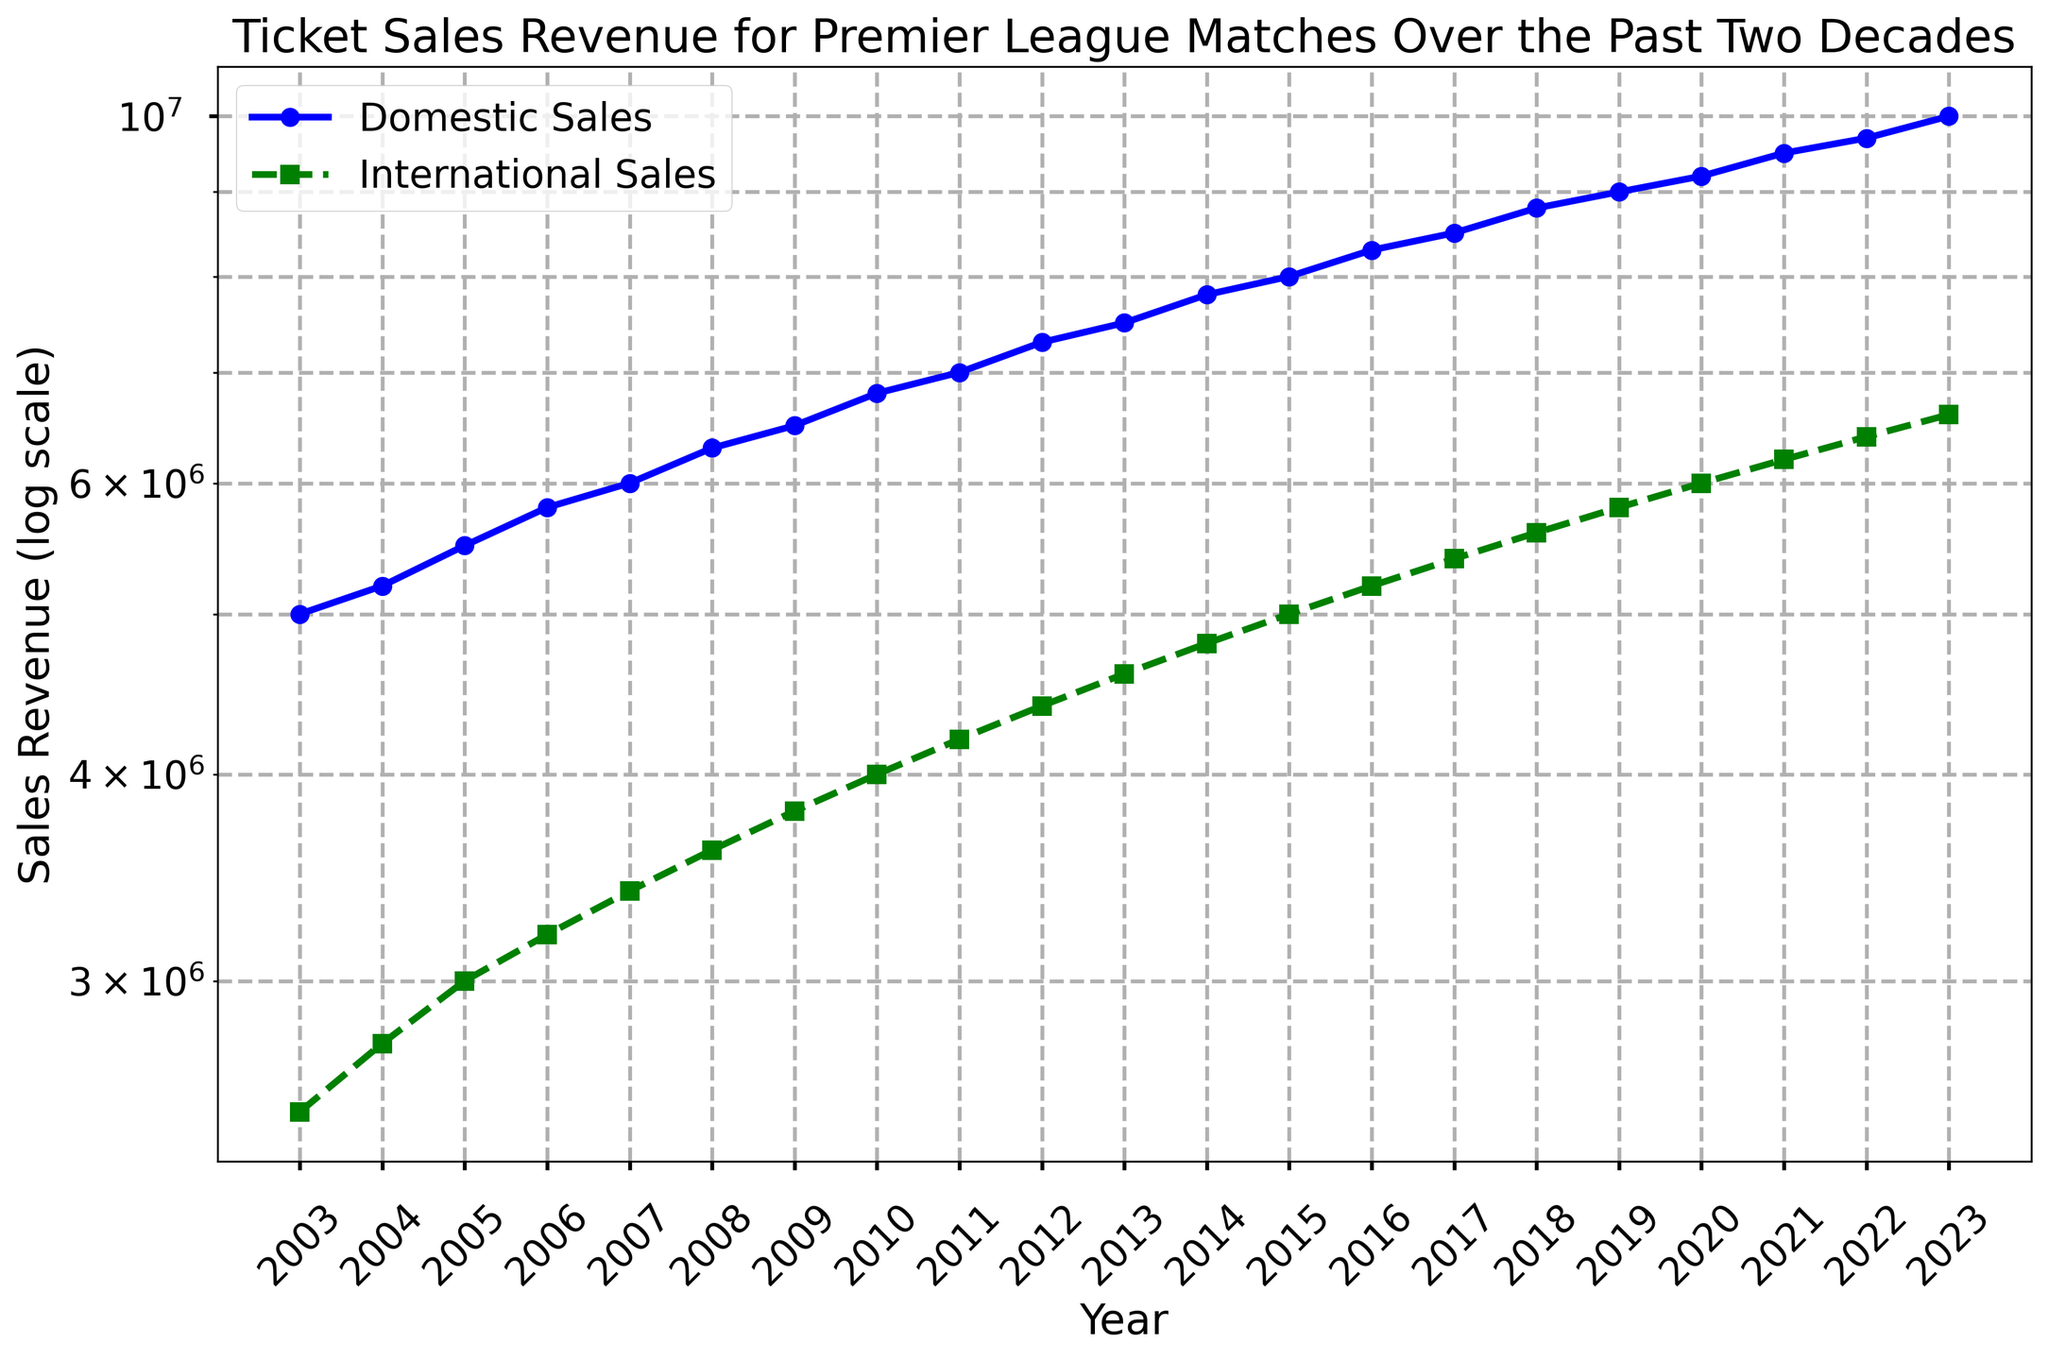Which year had the highest domestic sales revenue? The highest domestic sales revenue can be identified on the chart by noting the peak point of the blue line corresponding to Domestic Sales. The chart's title indicates the data spans up to 2023, so check which year has the highest blue marker.
Answer: 2023 In which year did international sales first exceed 5 million? To find the first instance where international sales exceeded 5 million, observe the green dashed line (International Sales) on the chart. Look for the first year where the marker for international sales crosses the 5 million mark.
Answer: 2015 What is the percentage increase in domestic sales from 2003 to 2023? To calculate the percentage increase: (Final Value - Initial Value) / Initial Value * 100. From the chart, the domestic sales in 2003 are 5,000,000 and in 2023 are 10,000,000. Percentage increase = (10,000,000 - 5,000,000) / 5,000,000 * 100.
Answer: 100% How does the growth rate of international sales between 2008 and 2018 compare to domestic sales in the same period? Determine the growth rates by subtracting the 2008 values from the 2018 values and then comparing them. For international sales: 5,600,000 - 3,600,000 = 2,000,000. For domestic sales: 8,800,000 - 6,300,000 = 2,500,000. Compare these values.
Answer: International Sales Growth: 2,000,000, Domestic Sales Growth: 2,500,000 Which sales type generally has a quicker growth rate over the given period, domestic or international? To determine growth rates, observe the slopes of the blue line for Domestic Sales and the green dashed line for International Sales. Steeper slopes indicate quicker growth rates. Comparing overall, check which line has a steeper average inclination.
Answer: Domestic Sales What is the difference in sales revenue between domestic and international sales in 2010? Find the values for domestic and international sales in 2010 on the chart: Domestic (blue line) is 6,800,000 and International (green dashed line) is 4,000,000. Difference = Domestic - International.
Answer: 2,800,000 Which year had the closest domestic and international sales values? Look for the year where the blue and green lines are closest to each other on the chart. Visually identify the smallest gap between the two lines.
Answer: 2004 How many years have passed until both domestic and international sales doubled compared to their 2003 values? Identify the target double values: Domestic (10,000,000) and International (5,000,000). Then see which year each sales type reaches approximately double the 2003 values.
Answer: Domestic: 2023 (20 years), International: 2023 (20 years) When did international sales start showing consistent year-on-year growth? Identify the initial year from which the green dashed line starts to consistently trend upward without any fall. Trace the yearly markers for international sales from the earliest upward trend.
Answer: 2005 What is the average annual increase in domestic sales over the two decades? To find the average annual increase: (Final Value - Initial Value) / Number of Years. For domestic sales: (10,000,000 - 5,000,000) / 20 years.
Answer: 250,000 